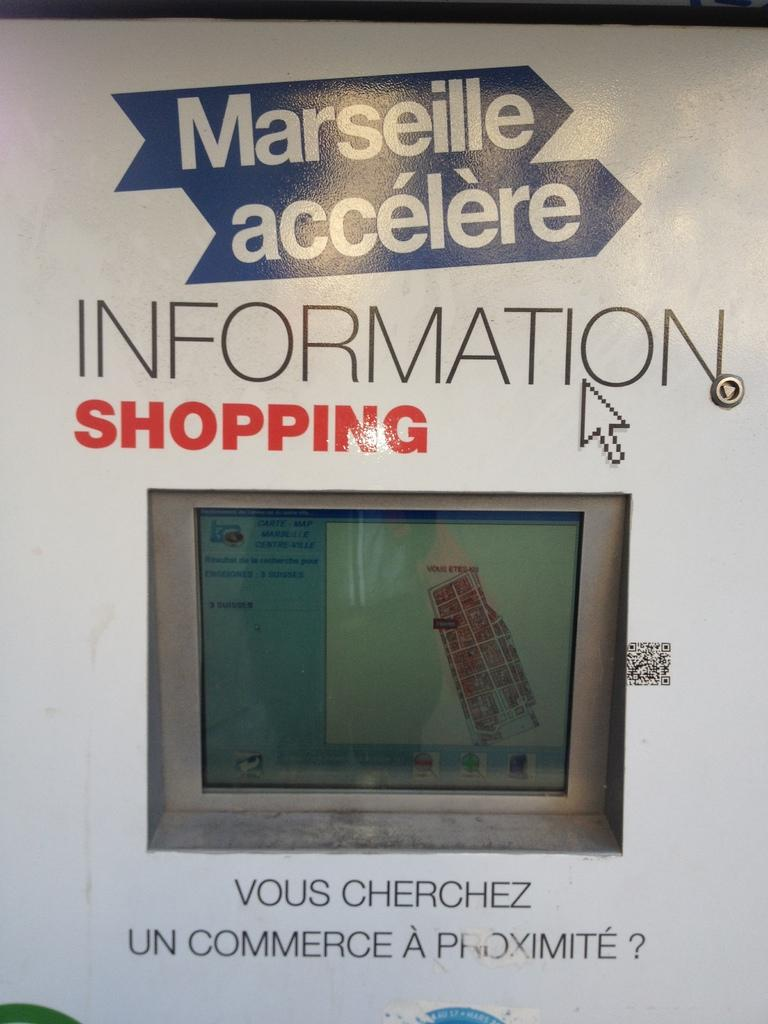<image>
Describe the image concisely. A French language book with the title INFORMATION SHOPPING. 